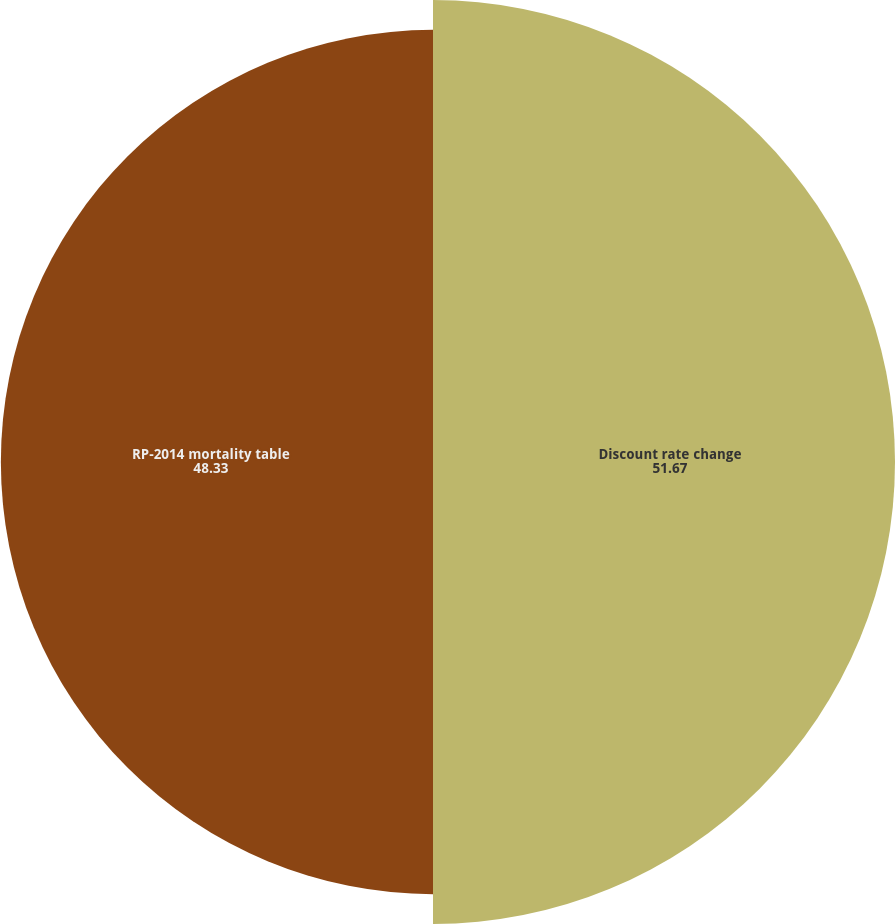<chart> <loc_0><loc_0><loc_500><loc_500><pie_chart><fcel>Discount rate change<fcel>RP-2014 mortality table<nl><fcel>51.67%<fcel>48.33%<nl></chart> 